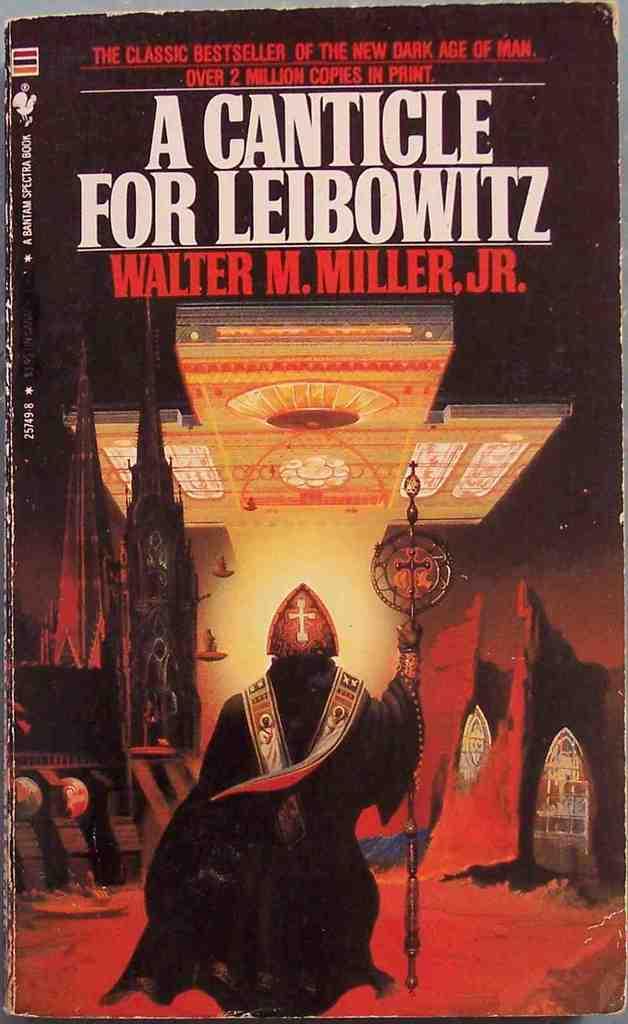How many copies of the book were made?
Make the answer very short. 2 million. Who wrote this book?
Provide a short and direct response. Walter m. miller, jr. 